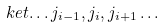<formula> <loc_0><loc_0><loc_500><loc_500>\ k e t { \dots j _ { i - 1 } , j _ { i } , j _ { i + 1 } \dots }</formula> 